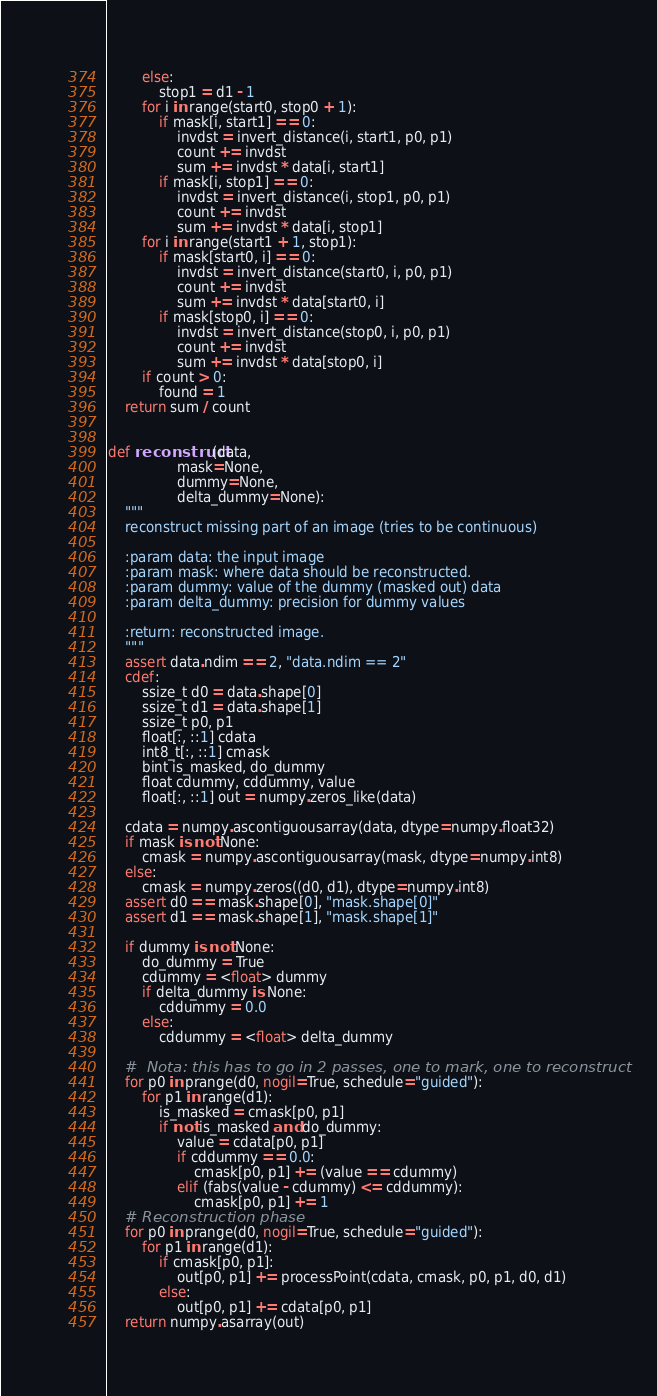Convert code to text. <code><loc_0><loc_0><loc_500><loc_500><_Cython_>        else:
            stop1 = d1 - 1
        for i in range(start0, stop0 + 1):
            if mask[i, start1] == 0:
                invdst = invert_distance(i, start1, p0, p1)
                count += invdst
                sum += invdst * data[i, start1]
            if mask[i, stop1] == 0:
                invdst = invert_distance(i, stop1, p0, p1)
                count += invdst
                sum += invdst * data[i, stop1]
        for i in range(start1 + 1, stop1):
            if mask[start0, i] == 0:
                invdst = invert_distance(start0, i, p0, p1)
                count += invdst
                sum += invdst * data[start0, i]
            if mask[stop0, i] == 0:
                invdst = invert_distance(stop0, i, p0, p1)
                count += invdst
                sum += invdst * data[stop0, i]
        if count > 0:
            found = 1
    return sum / count


def reconstruct(data, 
                mask=None, 
                dummy=None, 
                delta_dummy=None):
    """
    reconstruct missing part of an image (tries to be continuous)

    :param data: the input image
    :param mask: where data should be reconstructed.
    :param dummy: value of the dummy (masked out) data
    :param delta_dummy: precision for dummy values

    :return: reconstructed image.
    """
    assert data.ndim == 2, "data.ndim == 2"
    cdef:
        ssize_t d0 = data.shape[0]
        ssize_t d1 = data.shape[1]
        ssize_t p0, p1
        float[:, ::1] cdata
        int8_t[:, ::1] cmask 
        bint is_masked, do_dummy
        float cdummy, cddummy, value
        float[:, ::1] out = numpy.zeros_like(data)
        
    cdata = numpy.ascontiguousarray(data, dtype=numpy.float32)
    if mask is not None:
        cmask = numpy.ascontiguousarray(mask, dtype=numpy.int8)
    else:
        cmask = numpy.zeros((d0, d1), dtype=numpy.int8)
    assert d0 == mask.shape[0], "mask.shape[0]"
    assert d1 == mask.shape[1], "mask.shape[1]"

    if dummy is not None:
        do_dummy = True
        cdummy = <float> dummy
        if delta_dummy is None:
            cddummy = 0.0
        else:
            cddummy = <float> delta_dummy

    #  Nota: this has to go in 2 passes, one to mark, one to reconstruct  
    for p0 in prange(d0, nogil=True, schedule="guided"):
        for p1 in range(d1):
            is_masked = cmask[p0, p1]
            if not is_masked and do_dummy:
                value = cdata[p0, p1]
                if cddummy == 0.0:
                    cmask[p0, p1] += (value == cdummy)
                elif (fabs(value - cdummy) <= cddummy):
                    cmask[p0, p1] += 1
    # Reconstruction phase         
    for p0 in prange(d0, nogil=True, schedule="guided"):
        for p1 in range(d1):
            if cmask[p0, p1]:
                out[p0, p1] += processPoint(cdata, cmask, p0, p1, d0, d1)
            else:
                out[p0, p1] += cdata[p0, p1]
    return numpy.asarray(out)
</code> 